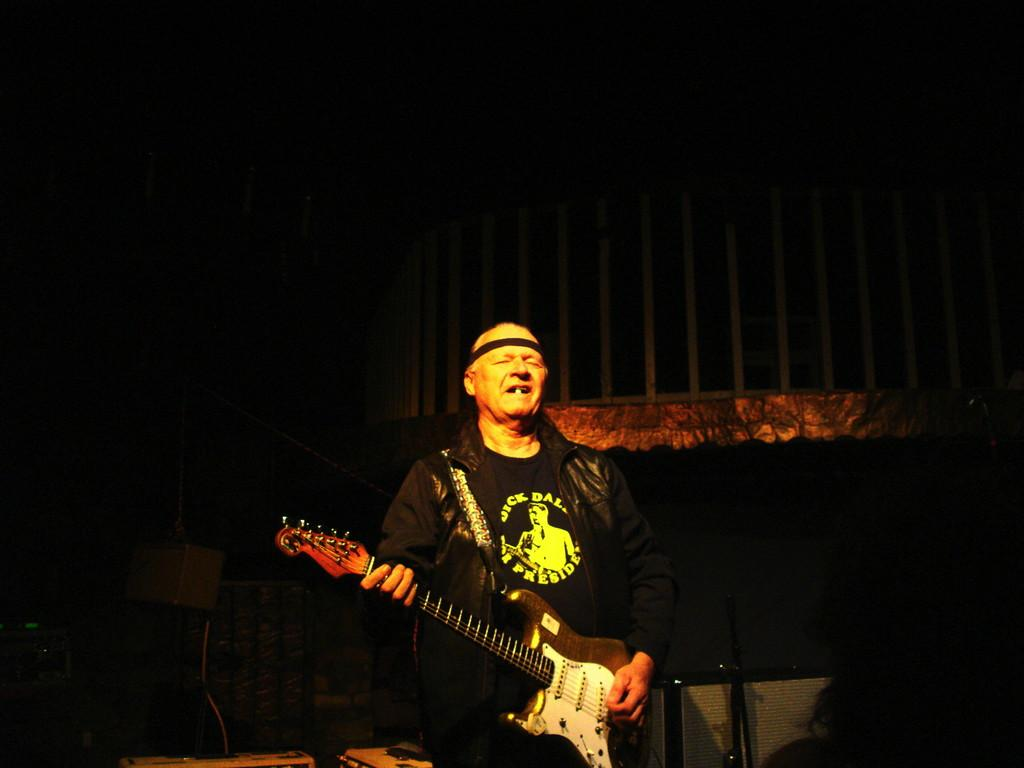What is the main subject of the image? There is a person in the image. What is the person doing in the image? The person is standing and holding a guitar. What can be observed about the background of the image? The background of the image is dark. Are there any icicles hanging from the wall in the image? There is no wall or icicles present in the image. What type of rifle is the person holding in the image? There is no rifle present in the image; the person is holding a guitar. 